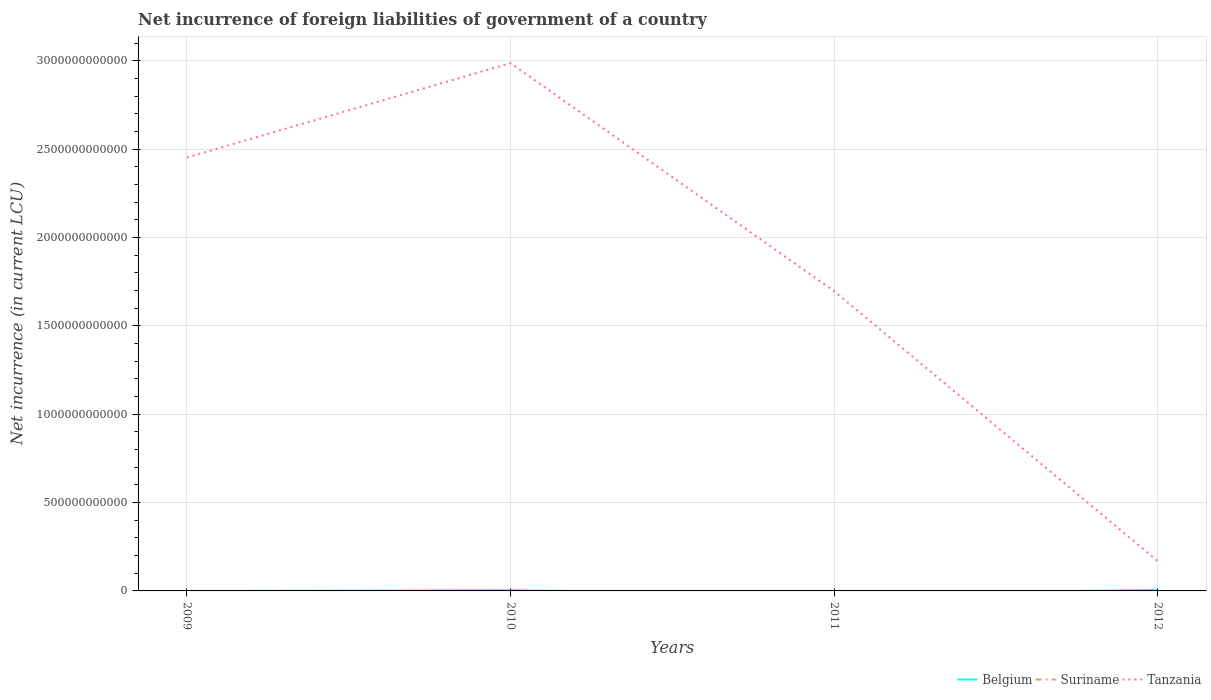How many different coloured lines are there?
Offer a terse response. 3. Across all years, what is the maximum net incurrence of foreign liabilities in Belgium?
Make the answer very short. 0. What is the total net incurrence of foreign liabilities in Suriname in the graph?
Your answer should be compact. -1.63e+08. What is the difference between the highest and the second highest net incurrence of foreign liabilities in Belgium?
Provide a succinct answer. 5.30e+09. What is the difference between the highest and the lowest net incurrence of foreign liabilities in Suriname?
Offer a very short reply. 2. Is the net incurrence of foreign liabilities in Suriname strictly greater than the net incurrence of foreign liabilities in Tanzania over the years?
Your answer should be very brief. Yes. How many lines are there?
Provide a short and direct response. 3. What is the difference between two consecutive major ticks on the Y-axis?
Offer a terse response. 5.00e+11. Are the values on the major ticks of Y-axis written in scientific E-notation?
Your answer should be very brief. No. What is the title of the graph?
Ensure brevity in your answer.  Net incurrence of foreign liabilities of government of a country. Does "Guam" appear as one of the legend labels in the graph?
Give a very brief answer. No. What is the label or title of the X-axis?
Your answer should be compact. Years. What is the label or title of the Y-axis?
Provide a succinct answer. Net incurrence (in current LCU). What is the Net incurrence (in current LCU) of Tanzania in 2009?
Your answer should be very brief. 2.45e+12. What is the Net incurrence (in current LCU) of Belgium in 2010?
Your answer should be very brief. 3.50e+09. What is the Net incurrence (in current LCU) of Suriname in 2010?
Keep it short and to the point. 1.84e+08. What is the Net incurrence (in current LCU) in Tanzania in 2010?
Ensure brevity in your answer.  2.99e+12. What is the Net incurrence (in current LCU) in Belgium in 2011?
Keep it short and to the point. 0. What is the Net incurrence (in current LCU) of Suriname in 2011?
Keep it short and to the point. 4.14e+08. What is the Net incurrence (in current LCU) of Tanzania in 2011?
Give a very brief answer. 1.70e+12. What is the Net incurrence (in current LCU) of Belgium in 2012?
Give a very brief answer. 5.30e+09. What is the Net incurrence (in current LCU) of Suriname in 2012?
Offer a terse response. 3.48e+08. What is the Net incurrence (in current LCU) of Tanzania in 2012?
Provide a short and direct response. 1.68e+11. Across all years, what is the maximum Net incurrence (in current LCU) in Belgium?
Make the answer very short. 5.30e+09. Across all years, what is the maximum Net incurrence (in current LCU) in Suriname?
Provide a succinct answer. 4.14e+08. Across all years, what is the maximum Net incurrence (in current LCU) of Tanzania?
Provide a succinct answer. 2.99e+12. Across all years, what is the minimum Net incurrence (in current LCU) of Belgium?
Give a very brief answer. 0. Across all years, what is the minimum Net incurrence (in current LCU) in Suriname?
Your response must be concise. 0. Across all years, what is the minimum Net incurrence (in current LCU) in Tanzania?
Provide a succinct answer. 1.68e+11. What is the total Net incurrence (in current LCU) of Belgium in the graph?
Offer a very short reply. 8.80e+09. What is the total Net incurrence (in current LCU) of Suriname in the graph?
Your answer should be very brief. 9.46e+08. What is the total Net incurrence (in current LCU) in Tanzania in the graph?
Keep it short and to the point. 7.30e+12. What is the difference between the Net incurrence (in current LCU) of Tanzania in 2009 and that in 2010?
Offer a very short reply. -5.34e+11. What is the difference between the Net incurrence (in current LCU) in Tanzania in 2009 and that in 2011?
Your answer should be compact. 7.56e+11. What is the difference between the Net incurrence (in current LCU) in Tanzania in 2009 and that in 2012?
Keep it short and to the point. 2.28e+12. What is the difference between the Net incurrence (in current LCU) of Suriname in 2010 and that in 2011?
Your answer should be very brief. -2.29e+08. What is the difference between the Net incurrence (in current LCU) in Tanzania in 2010 and that in 2011?
Provide a short and direct response. 1.29e+12. What is the difference between the Net incurrence (in current LCU) in Belgium in 2010 and that in 2012?
Keep it short and to the point. -1.80e+09. What is the difference between the Net incurrence (in current LCU) of Suriname in 2010 and that in 2012?
Keep it short and to the point. -1.63e+08. What is the difference between the Net incurrence (in current LCU) of Tanzania in 2010 and that in 2012?
Provide a short and direct response. 2.82e+12. What is the difference between the Net incurrence (in current LCU) in Suriname in 2011 and that in 2012?
Your answer should be compact. 6.60e+07. What is the difference between the Net incurrence (in current LCU) of Tanzania in 2011 and that in 2012?
Offer a very short reply. 1.53e+12. What is the difference between the Net incurrence (in current LCU) of Belgium in 2010 and the Net incurrence (in current LCU) of Suriname in 2011?
Your response must be concise. 3.08e+09. What is the difference between the Net incurrence (in current LCU) in Belgium in 2010 and the Net incurrence (in current LCU) in Tanzania in 2011?
Ensure brevity in your answer.  -1.69e+12. What is the difference between the Net incurrence (in current LCU) in Suriname in 2010 and the Net incurrence (in current LCU) in Tanzania in 2011?
Give a very brief answer. -1.70e+12. What is the difference between the Net incurrence (in current LCU) in Belgium in 2010 and the Net incurrence (in current LCU) in Suriname in 2012?
Offer a terse response. 3.15e+09. What is the difference between the Net incurrence (in current LCU) of Belgium in 2010 and the Net incurrence (in current LCU) of Tanzania in 2012?
Offer a very short reply. -1.64e+11. What is the difference between the Net incurrence (in current LCU) of Suriname in 2010 and the Net incurrence (in current LCU) of Tanzania in 2012?
Your response must be concise. -1.68e+11. What is the difference between the Net incurrence (in current LCU) in Suriname in 2011 and the Net incurrence (in current LCU) in Tanzania in 2012?
Offer a terse response. -1.67e+11. What is the average Net incurrence (in current LCU) in Belgium per year?
Your answer should be compact. 2.20e+09. What is the average Net incurrence (in current LCU) of Suriname per year?
Offer a very short reply. 2.36e+08. What is the average Net incurrence (in current LCU) in Tanzania per year?
Your answer should be compact. 1.83e+12. In the year 2010, what is the difference between the Net incurrence (in current LCU) of Belgium and Net incurrence (in current LCU) of Suriname?
Give a very brief answer. 3.31e+09. In the year 2010, what is the difference between the Net incurrence (in current LCU) of Belgium and Net incurrence (in current LCU) of Tanzania?
Offer a terse response. -2.98e+12. In the year 2010, what is the difference between the Net incurrence (in current LCU) in Suriname and Net incurrence (in current LCU) in Tanzania?
Provide a succinct answer. -2.99e+12. In the year 2011, what is the difference between the Net incurrence (in current LCU) of Suriname and Net incurrence (in current LCU) of Tanzania?
Your answer should be very brief. -1.70e+12. In the year 2012, what is the difference between the Net incurrence (in current LCU) of Belgium and Net incurrence (in current LCU) of Suriname?
Provide a succinct answer. 4.95e+09. In the year 2012, what is the difference between the Net incurrence (in current LCU) in Belgium and Net incurrence (in current LCU) in Tanzania?
Make the answer very short. -1.63e+11. In the year 2012, what is the difference between the Net incurrence (in current LCU) of Suriname and Net incurrence (in current LCU) of Tanzania?
Make the answer very short. -1.68e+11. What is the ratio of the Net incurrence (in current LCU) of Tanzania in 2009 to that in 2010?
Provide a succinct answer. 0.82. What is the ratio of the Net incurrence (in current LCU) of Tanzania in 2009 to that in 2011?
Your answer should be compact. 1.45. What is the ratio of the Net incurrence (in current LCU) of Tanzania in 2009 to that in 2012?
Give a very brief answer. 14.6. What is the ratio of the Net incurrence (in current LCU) of Suriname in 2010 to that in 2011?
Make the answer very short. 0.45. What is the ratio of the Net incurrence (in current LCU) of Tanzania in 2010 to that in 2011?
Ensure brevity in your answer.  1.76. What is the ratio of the Net incurrence (in current LCU) of Belgium in 2010 to that in 2012?
Give a very brief answer. 0.66. What is the ratio of the Net incurrence (in current LCU) of Suriname in 2010 to that in 2012?
Offer a terse response. 0.53. What is the ratio of the Net incurrence (in current LCU) in Tanzania in 2010 to that in 2012?
Your answer should be very brief. 17.79. What is the ratio of the Net incurrence (in current LCU) of Suriname in 2011 to that in 2012?
Keep it short and to the point. 1.19. What is the ratio of the Net incurrence (in current LCU) of Tanzania in 2011 to that in 2012?
Provide a succinct answer. 10.1. What is the difference between the highest and the second highest Net incurrence (in current LCU) of Suriname?
Your answer should be compact. 6.60e+07. What is the difference between the highest and the second highest Net incurrence (in current LCU) of Tanzania?
Keep it short and to the point. 5.34e+11. What is the difference between the highest and the lowest Net incurrence (in current LCU) in Belgium?
Make the answer very short. 5.30e+09. What is the difference between the highest and the lowest Net incurrence (in current LCU) in Suriname?
Offer a terse response. 4.14e+08. What is the difference between the highest and the lowest Net incurrence (in current LCU) of Tanzania?
Your answer should be compact. 2.82e+12. 